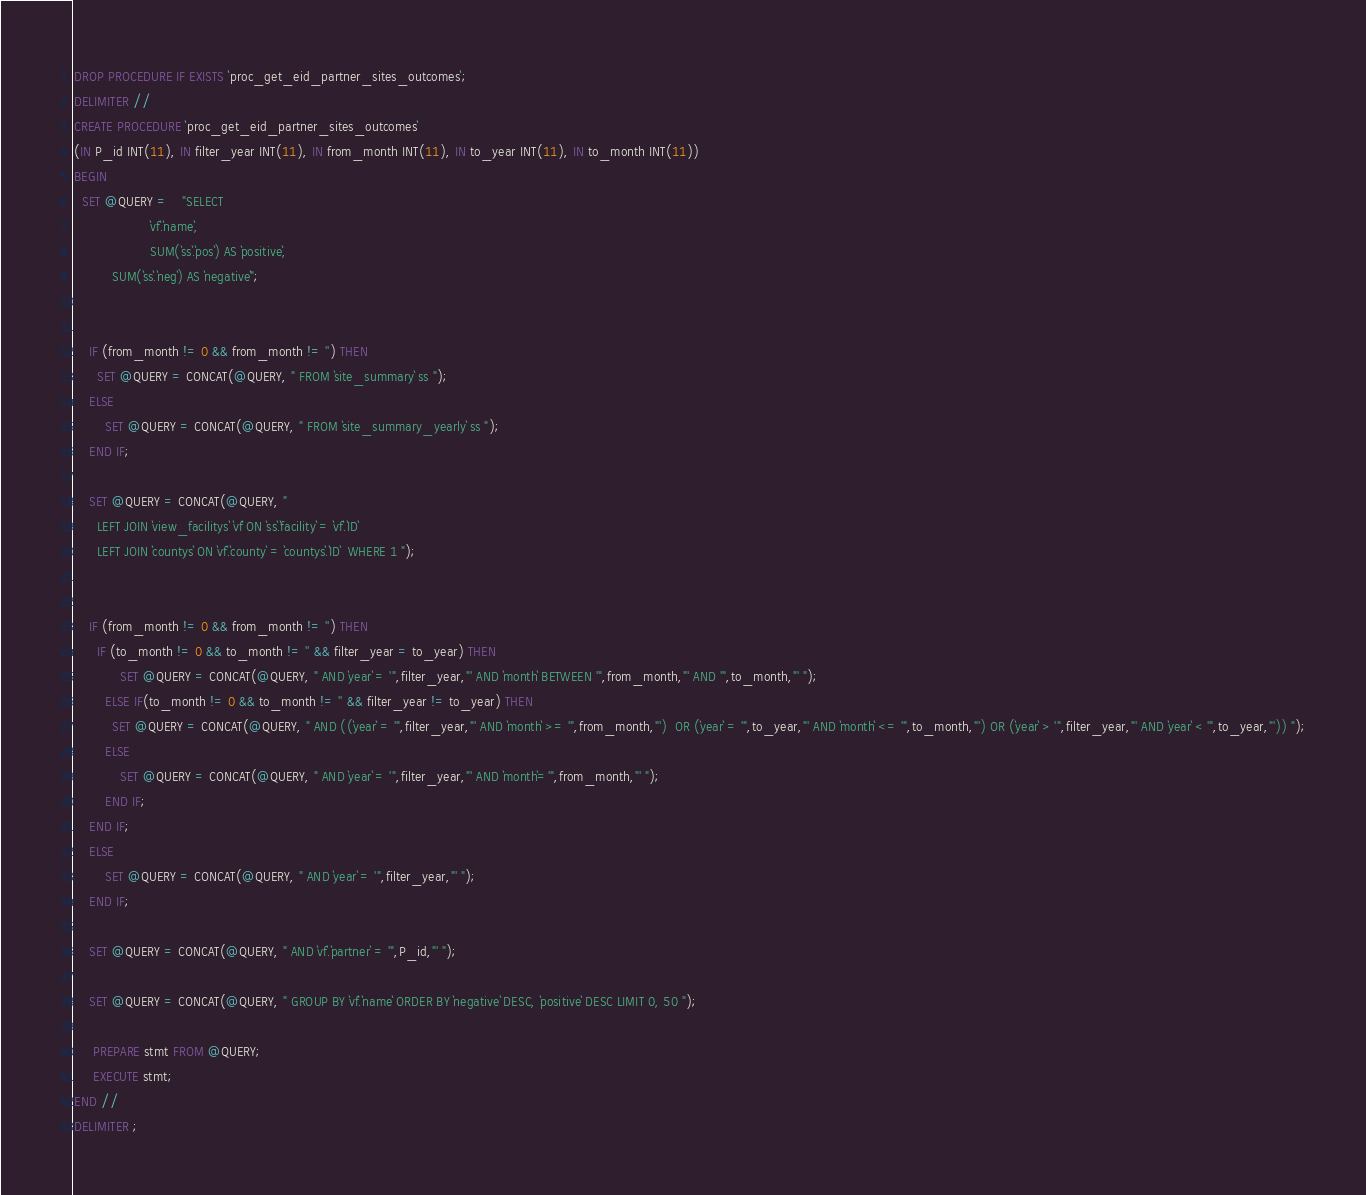<code> <loc_0><loc_0><loc_500><loc_500><_SQL_>DROP PROCEDURE IF EXISTS `proc_get_eid_partner_sites_outcomes`;
DELIMITER //
CREATE PROCEDURE `proc_get_eid_partner_sites_outcomes`
(IN P_id INT(11), IN filter_year INT(11), IN from_month INT(11), IN to_year INT(11), IN to_month INT(11))
BEGIN
  SET @QUERY =    "SELECT 
					`vf`.`name`,
					SUM(`ss`.`pos`) AS `positive`,
          SUM(`ss`.`neg`) AS `negative`";


    IF (from_month != 0 && from_month != '') THEN
      SET @QUERY = CONCAT(@QUERY, " FROM `site_summary` ss ");
    ELSE
        SET @QUERY = CONCAT(@QUERY, " FROM `site_summary_yearly` ss ");
    END IF;

    SET @QUERY = CONCAT(@QUERY, " 
      LEFT JOIN `view_facilitys` `vf` ON `ss`.`facility` = `vf`.`ID` 
      LEFT JOIN `countys` ON `vf`.`county` = `countys`.`ID`  WHERE 1 ");


    IF (from_month != 0 && from_month != '') THEN
      IF (to_month != 0 && to_month != '' && filter_year = to_year) THEN
            SET @QUERY = CONCAT(@QUERY, " AND `year` = '",filter_year,"' AND `month` BETWEEN '",from_month,"' AND '",to_month,"' ");
        ELSE IF(to_month != 0 && to_month != '' && filter_year != to_year) THEN
          SET @QUERY = CONCAT(@QUERY, " AND ((`year` = '",filter_year,"' AND `month` >= '",from_month,"')  OR (`year` = '",to_year,"' AND `month` <= '",to_month,"') OR (`year` > '",filter_year,"' AND `year` < '",to_year,"')) ");
        ELSE
            SET @QUERY = CONCAT(@QUERY, " AND `year` = '",filter_year,"' AND `month`='",from_month,"' ");
        END IF;
    END IF;
    ELSE
        SET @QUERY = CONCAT(@QUERY, " AND `year` = '",filter_year,"' ");
    END IF;

    SET @QUERY = CONCAT(@QUERY, " AND `vf`.`partner` = '",P_id,"' ");

    SET @QUERY = CONCAT(@QUERY, " GROUP BY `vf`.`name` ORDER BY `negative` DESC, `positive` DESC LIMIT 0, 50 ");

     PREPARE stmt FROM @QUERY;
     EXECUTE stmt;
END //
DELIMITER ;
</code> 